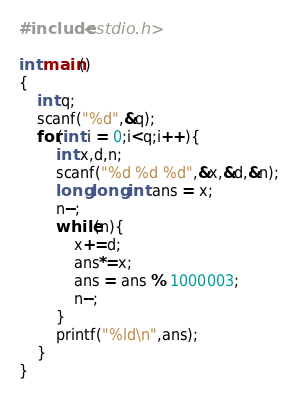Convert code to text. <code><loc_0><loc_0><loc_500><loc_500><_C_>#include<stdio.h>

int main()
{
	int q;
	scanf("%d",&q);
	for(int i = 0;i<q;i++){
		int x,d,n;
		scanf("%d %d %d",&x,&d,&n);
		long long int ans = x;
		n--;
		while(n){
			x+=d;
			ans*=x;
			ans = ans % 1000003;
			n--;
		}
		printf("%ld\n",ans);
	}
}</code> 